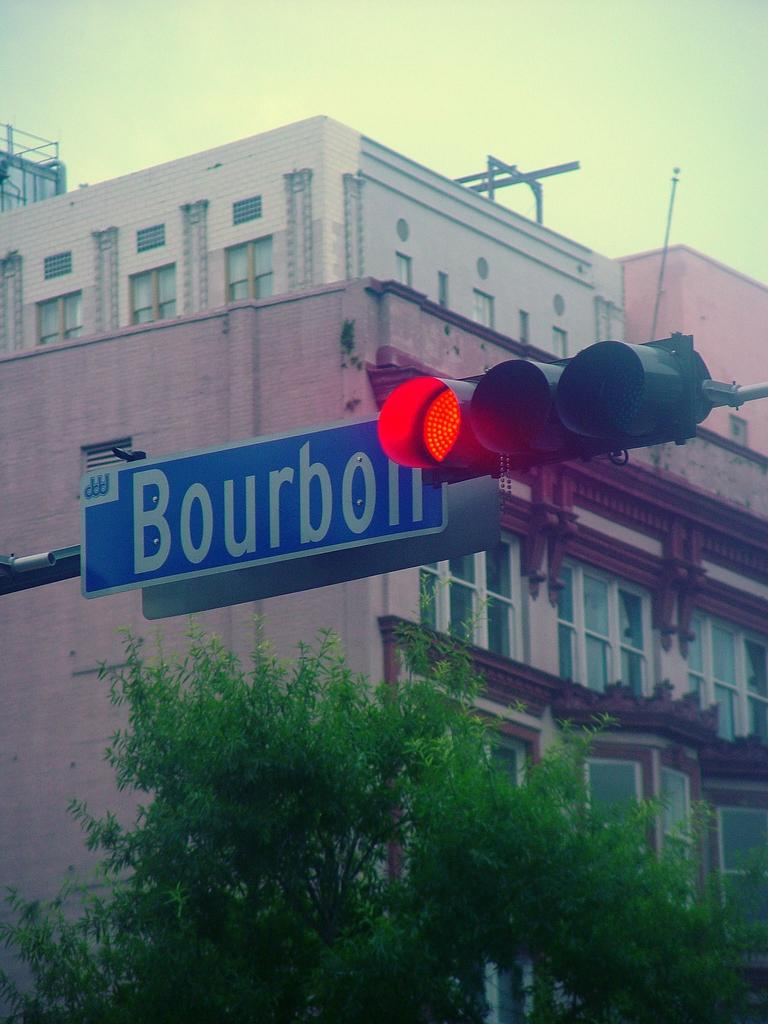<image>
Summarize the visual content of the image. A red light next to a Bourbon Street street sign. 